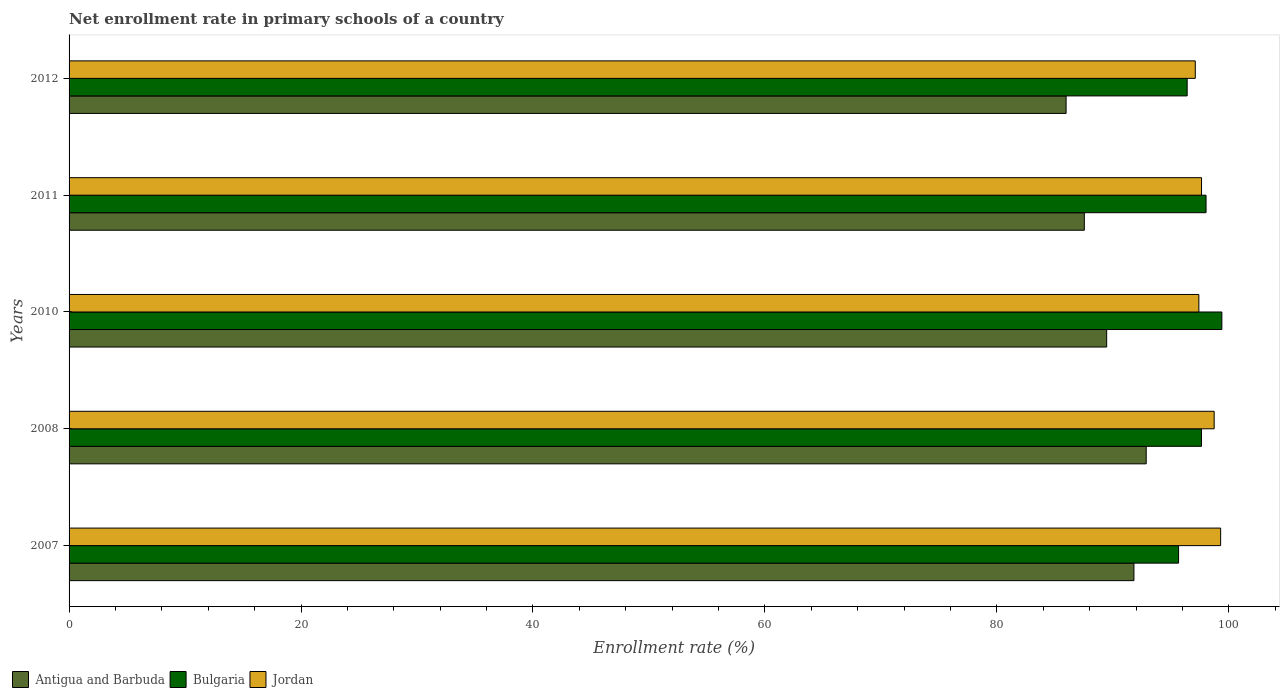How many different coloured bars are there?
Give a very brief answer. 3. How many groups of bars are there?
Provide a succinct answer. 5. Are the number of bars per tick equal to the number of legend labels?
Ensure brevity in your answer.  Yes. What is the label of the 1st group of bars from the top?
Provide a succinct answer. 2012. What is the enrollment rate in primary schools in Bulgaria in 2011?
Your response must be concise. 98.04. Across all years, what is the maximum enrollment rate in primary schools in Antigua and Barbuda?
Give a very brief answer. 92.88. Across all years, what is the minimum enrollment rate in primary schools in Jordan?
Your answer should be very brief. 97.11. In which year was the enrollment rate in primary schools in Antigua and Barbuda maximum?
Keep it short and to the point. 2008. What is the total enrollment rate in primary schools in Antigua and Barbuda in the graph?
Offer a terse response. 447.69. What is the difference between the enrollment rate in primary schools in Jordan in 2007 and that in 2008?
Your answer should be compact. 0.56. What is the difference between the enrollment rate in primary schools in Antigua and Barbuda in 2010 and the enrollment rate in primary schools in Bulgaria in 2008?
Make the answer very short. -8.17. What is the average enrollment rate in primary schools in Bulgaria per year?
Offer a very short reply. 97.43. In the year 2012, what is the difference between the enrollment rate in primary schools in Antigua and Barbuda and enrollment rate in primary schools in Jordan?
Provide a short and direct response. -11.14. In how many years, is the enrollment rate in primary schools in Antigua and Barbuda greater than 92 %?
Keep it short and to the point. 1. What is the ratio of the enrollment rate in primary schools in Jordan in 2008 to that in 2011?
Make the answer very short. 1.01. Is the difference between the enrollment rate in primary schools in Antigua and Barbuda in 2011 and 2012 greater than the difference between the enrollment rate in primary schools in Jordan in 2011 and 2012?
Provide a short and direct response. Yes. What is the difference between the highest and the second highest enrollment rate in primary schools in Bulgaria?
Your answer should be very brief. 1.36. What is the difference between the highest and the lowest enrollment rate in primary schools in Bulgaria?
Keep it short and to the point. 3.73. What does the 2nd bar from the top in 2010 represents?
Your answer should be compact. Bulgaria. How many bars are there?
Ensure brevity in your answer.  15. Are all the bars in the graph horizontal?
Provide a succinct answer. Yes. What is the difference between two consecutive major ticks on the X-axis?
Your response must be concise. 20. Does the graph contain any zero values?
Your answer should be very brief. No. Does the graph contain grids?
Offer a terse response. No. Where does the legend appear in the graph?
Keep it short and to the point. Bottom left. How many legend labels are there?
Keep it short and to the point. 3. What is the title of the graph?
Provide a short and direct response. Net enrollment rate in primary schools of a country. What is the label or title of the X-axis?
Your answer should be compact. Enrollment rate (%). What is the Enrollment rate (%) of Antigua and Barbuda in 2007?
Your response must be concise. 91.82. What is the Enrollment rate (%) in Bulgaria in 2007?
Offer a very short reply. 95.67. What is the Enrollment rate (%) of Jordan in 2007?
Offer a very short reply. 99.3. What is the Enrollment rate (%) in Antigua and Barbuda in 2008?
Provide a succinct answer. 92.88. What is the Enrollment rate (%) of Bulgaria in 2008?
Keep it short and to the point. 97.64. What is the Enrollment rate (%) in Jordan in 2008?
Your answer should be very brief. 98.74. What is the Enrollment rate (%) in Antigua and Barbuda in 2010?
Offer a terse response. 89.47. What is the Enrollment rate (%) in Bulgaria in 2010?
Provide a succinct answer. 99.4. What is the Enrollment rate (%) in Jordan in 2010?
Give a very brief answer. 97.42. What is the Enrollment rate (%) in Antigua and Barbuda in 2011?
Give a very brief answer. 87.54. What is the Enrollment rate (%) in Bulgaria in 2011?
Your response must be concise. 98.04. What is the Enrollment rate (%) in Jordan in 2011?
Provide a succinct answer. 97.65. What is the Enrollment rate (%) of Antigua and Barbuda in 2012?
Provide a succinct answer. 85.97. What is the Enrollment rate (%) in Bulgaria in 2012?
Your answer should be very brief. 96.41. What is the Enrollment rate (%) of Jordan in 2012?
Give a very brief answer. 97.11. Across all years, what is the maximum Enrollment rate (%) of Antigua and Barbuda?
Ensure brevity in your answer.  92.88. Across all years, what is the maximum Enrollment rate (%) of Bulgaria?
Make the answer very short. 99.4. Across all years, what is the maximum Enrollment rate (%) of Jordan?
Offer a very short reply. 99.3. Across all years, what is the minimum Enrollment rate (%) of Antigua and Barbuda?
Keep it short and to the point. 85.97. Across all years, what is the minimum Enrollment rate (%) in Bulgaria?
Your answer should be very brief. 95.67. Across all years, what is the minimum Enrollment rate (%) in Jordan?
Your response must be concise. 97.11. What is the total Enrollment rate (%) in Antigua and Barbuda in the graph?
Offer a very short reply. 447.69. What is the total Enrollment rate (%) of Bulgaria in the graph?
Provide a succinct answer. 487.16. What is the total Enrollment rate (%) in Jordan in the graph?
Give a very brief answer. 490.22. What is the difference between the Enrollment rate (%) of Antigua and Barbuda in 2007 and that in 2008?
Keep it short and to the point. -1.06. What is the difference between the Enrollment rate (%) of Bulgaria in 2007 and that in 2008?
Keep it short and to the point. -1.97. What is the difference between the Enrollment rate (%) in Jordan in 2007 and that in 2008?
Provide a short and direct response. 0.56. What is the difference between the Enrollment rate (%) in Antigua and Barbuda in 2007 and that in 2010?
Offer a very short reply. 2.35. What is the difference between the Enrollment rate (%) in Bulgaria in 2007 and that in 2010?
Provide a short and direct response. -3.73. What is the difference between the Enrollment rate (%) in Jordan in 2007 and that in 2010?
Your answer should be very brief. 1.88. What is the difference between the Enrollment rate (%) in Antigua and Barbuda in 2007 and that in 2011?
Offer a terse response. 4.28. What is the difference between the Enrollment rate (%) in Bulgaria in 2007 and that in 2011?
Give a very brief answer. -2.37. What is the difference between the Enrollment rate (%) of Jordan in 2007 and that in 2011?
Your answer should be compact. 1.65. What is the difference between the Enrollment rate (%) in Antigua and Barbuda in 2007 and that in 2012?
Offer a very short reply. 5.85. What is the difference between the Enrollment rate (%) of Bulgaria in 2007 and that in 2012?
Provide a short and direct response. -0.74. What is the difference between the Enrollment rate (%) of Jordan in 2007 and that in 2012?
Your answer should be compact. 2.19. What is the difference between the Enrollment rate (%) of Antigua and Barbuda in 2008 and that in 2010?
Provide a succinct answer. 3.41. What is the difference between the Enrollment rate (%) of Bulgaria in 2008 and that in 2010?
Your answer should be compact. -1.76. What is the difference between the Enrollment rate (%) of Jordan in 2008 and that in 2010?
Your response must be concise. 1.32. What is the difference between the Enrollment rate (%) in Antigua and Barbuda in 2008 and that in 2011?
Your response must be concise. 5.34. What is the difference between the Enrollment rate (%) of Bulgaria in 2008 and that in 2011?
Offer a terse response. -0.4. What is the difference between the Enrollment rate (%) in Jordan in 2008 and that in 2011?
Your answer should be compact. 1.09. What is the difference between the Enrollment rate (%) of Antigua and Barbuda in 2008 and that in 2012?
Keep it short and to the point. 6.91. What is the difference between the Enrollment rate (%) in Bulgaria in 2008 and that in 2012?
Give a very brief answer. 1.23. What is the difference between the Enrollment rate (%) in Jordan in 2008 and that in 2012?
Your answer should be compact. 1.63. What is the difference between the Enrollment rate (%) of Antigua and Barbuda in 2010 and that in 2011?
Your answer should be compact. 1.93. What is the difference between the Enrollment rate (%) of Bulgaria in 2010 and that in 2011?
Give a very brief answer. 1.36. What is the difference between the Enrollment rate (%) in Jordan in 2010 and that in 2011?
Keep it short and to the point. -0.23. What is the difference between the Enrollment rate (%) in Antigua and Barbuda in 2010 and that in 2012?
Your response must be concise. 3.5. What is the difference between the Enrollment rate (%) of Bulgaria in 2010 and that in 2012?
Provide a short and direct response. 2.99. What is the difference between the Enrollment rate (%) in Jordan in 2010 and that in 2012?
Ensure brevity in your answer.  0.31. What is the difference between the Enrollment rate (%) of Antigua and Barbuda in 2011 and that in 2012?
Your answer should be very brief. 1.57. What is the difference between the Enrollment rate (%) of Bulgaria in 2011 and that in 2012?
Offer a very short reply. 1.63. What is the difference between the Enrollment rate (%) in Jordan in 2011 and that in 2012?
Your response must be concise. 0.54. What is the difference between the Enrollment rate (%) in Antigua and Barbuda in 2007 and the Enrollment rate (%) in Bulgaria in 2008?
Offer a very short reply. -5.82. What is the difference between the Enrollment rate (%) in Antigua and Barbuda in 2007 and the Enrollment rate (%) in Jordan in 2008?
Offer a very short reply. -6.92. What is the difference between the Enrollment rate (%) of Bulgaria in 2007 and the Enrollment rate (%) of Jordan in 2008?
Provide a succinct answer. -3.07. What is the difference between the Enrollment rate (%) in Antigua and Barbuda in 2007 and the Enrollment rate (%) in Bulgaria in 2010?
Give a very brief answer. -7.58. What is the difference between the Enrollment rate (%) in Antigua and Barbuda in 2007 and the Enrollment rate (%) in Jordan in 2010?
Make the answer very short. -5.6. What is the difference between the Enrollment rate (%) of Bulgaria in 2007 and the Enrollment rate (%) of Jordan in 2010?
Make the answer very short. -1.75. What is the difference between the Enrollment rate (%) of Antigua and Barbuda in 2007 and the Enrollment rate (%) of Bulgaria in 2011?
Ensure brevity in your answer.  -6.22. What is the difference between the Enrollment rate (%) in Antigua and Barbuda in 2007 and the Enrollment rate (%) in Jordan in 2011?
Your answer should be compact. -5.83. What is the difference between the Enrollment rate (%) in Bulgaria in 2007 and the Enrollment rate (%) in Jordan in 2011?
Give a very brief answer. -1.98. What is the difference between the Enrollment rate (%) of Antigua and Barbuda in 2007 and the Enrollment rate (%) of Bulgaria in 2012?
Give a very brief answer. -4.59. What is the difference between the Enrollment rate (%) of Antigua and Barbuda in 2007 and the Enrollment rate (%) of Jordan in 2012?
Provide a short and direct response. -5.29. What is the difference between the Enrollment rate (%) of Bulgaria in 2007 and the Enrollment rate (%) of Jordan in 2012?
Offer a very short reply. -1.44. What is the difference between the Enrollment rate (%) of Antigua and Barbuda in 2008 and the Enrollment rate (%) of Bulgaria in 2010?
Your answer should be very brief. -6.52. What is the difference between the Enrollment rate (%) of Antigua and Barbuda in 2008 and the Enrollment rate (%) of Jordan in 2010?
Provide a succinct answer. -4.54. What is the difference between the Enrollment rate (%) in Bulgaria in 2008 and the Enrollment rate (%) in Jordan in 2010?
Provide a succinct answer. 0.22. What is the difference between the Enrollment rate (%) in Antigua and Barbuda in 2008 and the Enrollment rate (%) in Bulgaria in 2011?
Provide a succinct answer. -5.16. What is the difference between the Enrollment rate (%) in Antigua and Barbuda in 2008 and the Enrollment rate (%) in Jordan in 2011?
Keep it short and to the point. -4.77. What is the difference between the Enrollment rate (%) of Bulgaria in 2008 and the Enrollment rate (%) of Jordan in 2011?
Your response must be concise. -0.01. What is the difference between the Enrollment rate (%) in Antigua and Barbuda in 2008 and the Enrollment rate (%) in Bulgaria in 2012?
Offer a very short reply. -3.53. What is the difference between the Enrollment rate (%) in Antigua and Barbuda in 2008 and the Enrollment rate (%) in Jordan in 2012?
Your answer should be very brief. -4.23. What is the difference between the Enrollment rate (%) of Bulgaria in 2008 and the Enrollment rate (%) of Jordan in 2012?
Make the answer very short. 0.53. What is the difference between the Enrollment rate (%) of Antigua and Barbuda in 2010 and the Enrollment rate (%) of Bulgaria in 2011?
Provide a succinct answer. -8.57. What is the difference between the Enrollment rate (%) of Antigua and Barbuda in 2010 and the Enrollment rate (%) of Jordan in 2011?
Provide a succinct answer. -8.18. What is the difference between the Enrollment rate (%) in Bulgaria in 2010 and the Enrollment rate (%) in Jordan in 2011?
Your response must be concise. 1.75. What is the difference between the Enrollment rate (%) of Antigua and Barbuda in 2010 and the Enrollment rate (%) of Bulgaria in 2012?
Offer a terse response. -6.94. What is the difference between the Enrollment rate (%) of Antigua and Barbuda in 2010 and the Enrollment rate (%) of Jordan in 2012?
Give a very brief answer. -7.64. What is the difference between the Enrollment rate (%) of Bulgaria in 2010 and the Enrollment rate (%) of Jordan in 2012?
Ensure brevity in your answer.  2.29. What is the difference between the Enrollment rate (%) in Antigua and Barbuda in 2011 and the Enrollment rate (%) in Bulgaria in 2012?
Give a very brief answer. -8.87. What is the difference between the Enrollment rate (%) in Antigua and Barbuda in 2011 and the Enrollment rate (%) in Jordan in 2012?
Provide a succinct answer. -9.57. What is the difference between the Enrollment rate (%) of Bulgaria in 2011 and the Enrollment rate (%) of Jordan in 2012?
Keep it short and to the point. 0.93. What is the average Enrollment rate (%) in Antigua and Barbuda per year?
Make the answer very short. 89.54. What is the average Enrollment rate (%) of Bulgaria per year?
Your answer should be very brief. 97.43. What is the average Enrollment rate (%) in Jordan per year?
Keep it short and to the point. 98.04. In the year 2007, what is the difference between the Enrollment rate (%) of Antigua and Barbuda and Enrollment rate (%) of Bulgaria?
Make the answer very short. -3.85. In the year 2007, what is the difference between the Enrollment rate (%) of Antigua and Barbuda and Enrollment rate (%) of Jordan?
Give a very brief answer. -7.48. In the year 2007, what is the difference between the Enrollment rate (%) in Bulgaria and Enrollment rate (%) in Jordan?
Provide a succinct answer. -3.63. In the year 2008, what is the difference between the Enrollment rate (%) in Antigua and Barbuda and Enrollment rate (%) in Bulgaria?
Give a very brief answer. -4.76. In the year 2008, what is the difference between the Enrollment rate (%) in Antigua and Barbuda and Enrollment rate (%) in Jordan?
Offer a terse response. -5.86. In the year 2008, what is the difference between the Enrollment rate (%) of Bulgaria and Enrollment rate (%) of Jordan?
Offer a very short reply. -1.1. In the year 2010, what is the difference between the Enrollment rate (%) in Antigua and Barbuda and Enrollment rate (%) in Bulgaria?
Offer a terse response. -9.93. In the year 2010, what is the difference between the Enrollment rate (%) in Antigua and Barbuda and Enrollment rate (%) in Jordan?
Offer a terse response. -7.95. In the year 2010, what is the difference between the Enrollment rate (%) in Bulgaria and Enrollment rate (%) in Jordan?
Your answer should be very brief. 1.98. In the year 2011, what is the difference between the Enrollment rate (%) in Antigua and Barbuda and Enrollment rate (%) in Bulgaria?
Your response must be concise. -10.49. In the year 2011, what is the difference between the Enrollment rate (%) of Antigua and Barbuda and Enrollment rate (%) of Jordan?
Your answer should be very brief. -10.11. In the year 2011, what is the difference between the Enrollment rate (%) in Bulgaria and Enrollment rate (%) in Jordan?
Provide a short and direct response. 0.39. In the year 2012, what is the difference between the Enrollment rate (%) in Antigua and Barbuda and Enrollment rate (%) in Bulgaria?
Your answer should be compact. -10.44. In the year 2012, what is the difference between the Enrollment rate (%) of Antigua and Barbuda and Enrollment rate (%) of Jordan?
Make the answer very short. -11.14. In the year 2012, what is the difference between the Enrollment rate (%) in Bulgaria and Enrollment rate (%) in Jordan?
Offer a terse response. -0.7. What is the ratio of the Enrollment rate (%) in Antigua and Barbuda in 2007 to that in 2008?
Provide a succinct answer. 0.99. What is the ratio of the Enrollment rate (%) in Bulgaria in 2007 to that in 2008?
Your answer should be very brief. 0.98. What is the ratio of the Enrollment rate (%) of Jordan in 2007 to that in 2008?
Your response must be concise. 1.01. What is the ratio of the Enrollment rate (%) in Antigua and Barbuda in 2007 to that in 2010?
Make the answer very short. 1.03. What is the ratio of the Enrollment rate (%) in Bulgaria in 2007 to that in 2010?
Your response must be concise. 0.96. What is the ratio of the Enrollment rate (%) of Jordan in 2007 to that in 2010?
Offer a very short reply. 1.02. What is the ratio of the Enrollment rate (%) of Antigua and Barbuda in 2007 to that in 2011?
Make the answer very short. 1.05. What is the ratio of the Enrollment rate (%) of Bulgaria in 2007 to that in 2011?
Give a very brief answer. 0.98. What is the ratio of the Enrollment rate (%) in Jordan in 2007 to that in 2011?
Your response must be concise. 1.02. What is the ratio of the Enrollment rate (%) of Antigua and Barbuda in 2007 to that in 2012?
Ensure brevity in your answer.  1.07. What is the ratio of the Enrollment rate (%) of Bulgaria in 2007 to that in 2012?
Keep it short and to the point. 0.99. What is the ratio of the Enrollment rate (%) in Jordan in 2007 to that in 2012?
Make the answer very short. 1.02. What is the ratio of the Enrollment rate (%) of Antigua and Barbuda in 2008 to that in 2010?
Your answer should be compact. 1.04. What is the ratio of the Enrollment rate (%) in Bulgaria in 2008 to that in 2010?
Offer a terse response. 0.98. What is the ratio of the Enrollment rate (%) of Jordan in 2008 to that in 2010?
Ensure brevity in your answer.  1.01. What is the ratio of the Enrollment rate (%) in Antigua and Barbuda in 2008 to that in 2011?
Your answer should be compact. 1.06. What is the ratio of the Enrollment rate (%) in Jordan in 2008 to that in 2011?
Your response must be concise. 1.01. What is the ratio of the Enrollment rate (%) of Antigua and Barbuda in 2008 to that in 2012?
Offer a very short reply. 1.08. What is the ratio of the Enrollment rate (%) of Bulgaria in 2008 to that in 2012?
Keep it short and to the point. 1.01. What is the ratio of the Enrollment rate (%) in Jordan in 2008 to that in 2012?
Provide a succinct answer. 1.02. What is the ratio of the Enrollment rate (%) in Antigua and Barbuda in 2010 to that in 2011?
Keep it short and to the point. 1.02. What is the ratio of the Enrollment rate (%) of Bulgaria in 2010 to that in 2011?
Offer a terse response. 1.01. What is the ratio of the Enrollment rate (%) in Antigua and Barbuda in 2010 to that in 2012?
Your response must be concise. 1.04. What is the ratio of the Enrollment rate (%) of Bulgaria in 2010 to that in 2012?
Make the answer very short. 1.03. What is the ratio of the Enrollment rate (%) of Jordan in 2010 to that in 2012?
Keep it short and to the point. 1. What is the ratio of the Enrollment rate (%) of Antigua and Barbuda in 2011 to that in 2012?
Make the answer very short. 1.02. What is the ratio of the Enrollment rate (%) in Bulgaria in 2011 to that in 2012?
Give a very brief answer. 1.02. What is the ratio of the Enrollment rate (%) in Jordan in 2011 to that in 2012?
Your response must be concise. 1.01. What is the difference between the highest and the second highest Enrollment rate (%) of Antigua and Barbuda?
Offer a terse response. 1.06. What is the difference between the highest and the second highest Enrollment rate (%) of Bulgaria?
Keep it short and to the point. 1.36. What is the difference between the highest and the second highest Enrollment rate (%) in Jordan?
Offer a terse response. 0.56. What is the difference between the highest and the lowest Enrollment rate (%) in Antigua and Barbuda?
Provide a succinct answer. 6.91. What is the difference between the highest and the lowest Enrollment rate (%) in Bulgaria?
Provide a short and direct response. 3.73. What is the difference between the highest and the lowest Enrollment rate (%) in Jordan?
Make the answer very short. 2.19. 